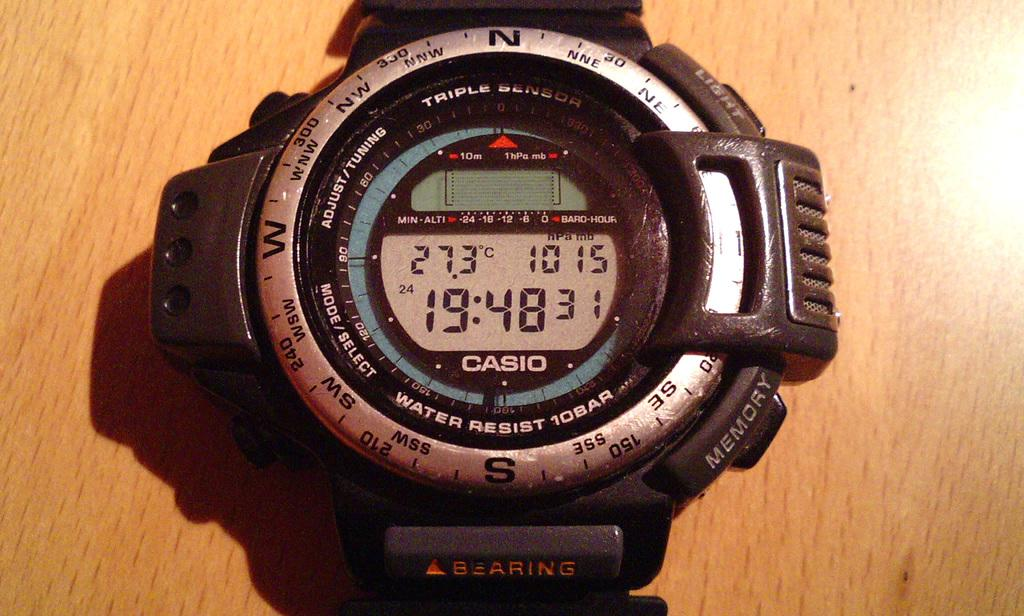<image>
Describe the image concisely. White and silver wristwatch which says CASIO on it. 